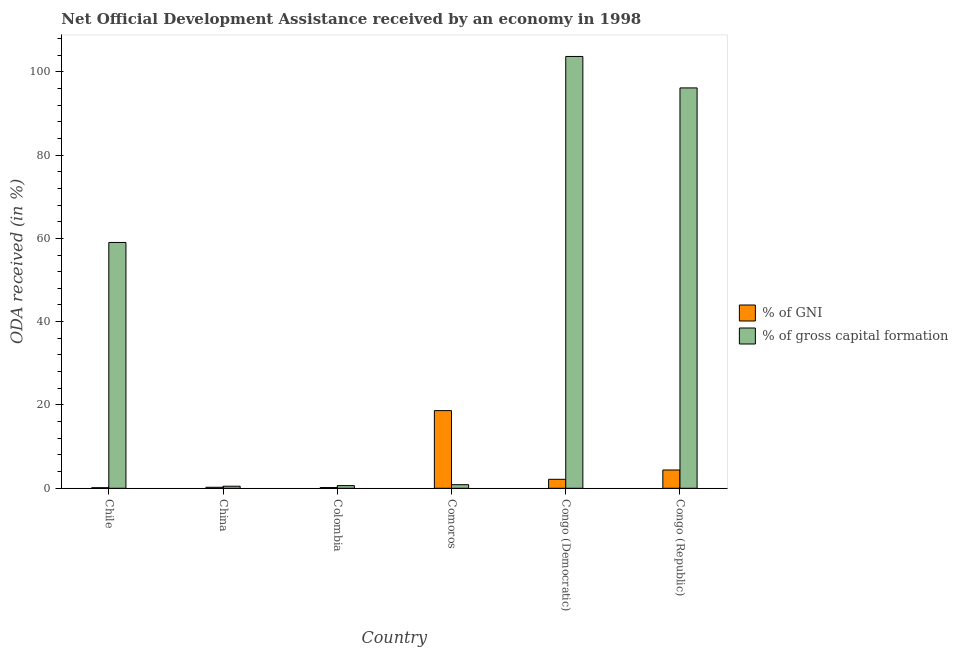How many different coloured bars are there?
Offer a very short reply. 2. Are the number of bars per tick equal to the number of legend labels?
Your response must be concise. Yes. Are the number of bars on each tick of the X-axis equal?
Keep it short and to the point. Yes. How many bars are there on the 2nd tick from the right?
Provide a short and direct response. 2. What is the label of the 6th group of bars from the left?
Give a very brief answer. Congo (Republic). In how many cases, is the number of bars for a given country not equal to the number of legend labels?
Provide a short and direct response. 0. What is the oda received as percentage of gni in Congo (Democratic)?
Provide a short and direct response. 2.15. Across all countries, what is the maximum oda received as percentage of gross capital formation?
Give a very brief answer. 103.67. Across all countries, what is the minimum oda received as percentage of gross capital formation?
Offer a terse response. 0.5. In which country was the oda received as percentage of gross capital formation maximum?
Ensure brevity in your answer.  Congo (Democratic). In which country was the oda received as percentage of gross capital formation minimum?
Make the answer very short. China. What is the total oda received as percentage of gross capital formation in the graph?
Keep it short and to the point. 260.8. What is the difference between the oda received as percentage of gni in Comoros and that in Congo (Republic)?
Give a very brief answer. 14.25. What is the difference between the oda received as percentage of gni in Congo (Republic) and the oda received as percentage of gross capital formation in China?
Ensure brevity in your answer.  3.89. What is the average oda received as percentage of gni per country?
Your answer should be very brief. 4.29. What is the difference between the oda received as percentage of gross capital formation and oda received as percentage of gni in China?
Offer a very short reply. 0.26. In how many countries, is the oda received as percentage of gni greater than 80 %?
Provide a short and direct response. 0. What is the ratio of the oda received as percentage of gross capital formation in Comoros to that in Congo (Republic)?
Your response must be concise. 0.01. Is the oda received as percentage of gross capital formation in China less than that in Comoros?
Provide a short and direct response. Yes. What is the difference between the highest and the second highest oda received as percentage of gross capital formation?
Give a very brief answer. 7.55. What is the difference between the highest and the lowest oda received as percentage of gross capital formation?
Offer a terse response. 103.17. Is the sum of the oda received as percentage of gross capital formation in Chile and Congo (Democratic) greater than the maximum oda received as percentage of gni across all countries?
Offer a very short reply. Yes. What does the 2nd bar from the left in Comoros represents?
Make the answer very short. % of gross capital formation. What does the 1st bar from the right in China represents?
Provide a succinct answer. % of gross capital formation. Are the values on the major ticks of Y-axis written in scientific E-notation?
Ensure brevity in your answer.  No. How are the legend labels stacked?
Keep it short and to the point. Vertical. What is the title of the graph?
Offer a very short reply. Net Official Development Assistance received by an economy in 1998. What is the label or title of the Y-axis?
Your answer should be very brief. ODA received (in %). What is the ODA received (in %) in % of GNI in Chile?
Ensure brevity in your answer.  0.14. What is the ODA received (in %) in % of gross capital formation in Chile?
Provide a succinct answer. 59.01. What is the ODA received (in %) of % of GNI in China?
Make the answer very short. 0.24. What is the ODA received (in %) in % of gross capital formation in China?
Provide a succinct answer. 0.5. What is the ODA received (in %) in % of GNI in Colombia?
Keep it short and to the point. 0.17. What is the ODA received (in %) in % of gross capital formation in Colombia?
Provide a succinct answer. 0.64. What is the ODA received (in %) in % of GNI in Comoros?
Your answer should be compact. 18.64. What is the ODA received (in %) of % of gross capital formation in Comoros?
Ensure brevity in your answer.  0.86. What is the ODA received (in %) in % of GNI in Congo (Democratic)?
Your response must be concise. 2.15. What is the ODA received (in %) in % of gross capital formation in Congo (Democratic)?
Offer a very short reply. 103.67. What is the ODA received (in %) in % of GNI in Congo (Republic)?
Provide a succinct answer. 4.39. What is the ODA received (in %) of % of gross capital formation in Congo (Republic)?
Your answer should be very brief. 96.12. Across all countries, what is the maximum ODA received (in %) of % of GNI?
Give a very brief answer. 18.64. Across all countries, what is the maximum ODA received (in %) in % of gross capital formation?
Give a very brief answer. 103.67. Across all countries, what is the minimum ODA received (in %) of % of GNI?
Make the answer very short. 0.14. Across all countries, what is the minimum ODA received (in %) of % of gross capital formation?
Keep it short and to the point. 0.5. What is the total ODA received (in %) in % of GNI in the graph?
Ensure brevity in your answer.  25.74. What is the total ODA received (in %) of % of gross capital formation in the graph?
Your answer should be very brief. 260.8. What is the difference between the ODA received (in %) in % of GNI in Chile and that in China?
Ensure brevity in your answer.  -0.1. What is the difference between the ODA received (in %) of % of gross capital formation in Chile and that in China?
Your answer should be very brief. 58.52. What is the difference between the ODA received (in %) of % of GNI in Chile and that in Colombia?
Offer a very short reply. -0.04. What is the difference between the ODA received (in %) of % of gross capital formation in Chile and that in Colombia?
Your answer should be compact. 58.37. What is the difference between the ODA received (in %) of % of GNI in Chile and that in Comoros?
Make the answer very short. -18.51. What is the difference between the ODA received (in %) of % of gross capital formation in Chile and that in Comoros?
Your answer should be compact. 58.15. What is the difference between the ODA received (in %) of % of GNI in Chile and that in Congo (Democratic)?
Your answer should be very brief. -2.02. What is the difference between the ODA received (in %) in % of gross capital formation in Chile and that in Congo (Democratic)?
Offer a very short reply. -44.65. What is the difference between the ODA received (in %) in % of GNI in Chile and that in Congo (Republic)?
Your response must be concise. -4.25. What is the difference between the ODA received (in %) in % of gross capital formation in Chile and that in Congo (Republic)?
Your response must be concise. -37.1. What is the difference between the ODA received (in %) of % of GNI in China and that in Colombia?
Give a very brief answer. 0.07. What is the difference between the ODA received (in %) of % of gross capital formation in China and that in Colombia?
Provide a succinct answer. -0.15. What is the difference between the ODA received (in %) in % of GNI in China and that in Comoros?
Make the answer very short. -18.4. What is the difference between the ODA received (in %) of % of gross capital formation in China and that in Comoros?
Offer a terse response. -0.36. What is the difference between the ODA received (in %) in % of GNI in China and that in Congo (Democratic)?
Offer a terse response. -1.91. What is the difference between the ODA received (in %) of % of gross capital formation in China and that in Congo (Democratic)?
Offer a very short reply. -103.17. What is the difference between the ODA received (in %) of % of GNI in China and that in Congo (Republic)?
Give a very brief answer. -4.15. What is the difference between the ODA received (in %) of % of gross capital formation in China and that in Congo (Republic)?
Your response must be concise. -95.62. What is the difference between the ODA received (in %) in % of GNI in Colombia and that in Comoros?
Ensure brevity in your answer.  -18.47. What is the difference between the ODA received (in %) in % of gross capital formation in Colombia and that in Comoros?
Offer a terse response. -0.22. What is the difference between the ODA received (in %) in % of GNI in Colombia and that in Congo (Democratic)?
Your answer should be very brief. -1.98. What is the difference between the ODA received (in %) in % of gross capital formation in Colombia and that in Congo (Democratic)?
Make the answer very short. -103.02. What is the difference between the ODA received (in %) of % of GNI in Colombia and that in Congo (Republic)?
Your answer should be compact. -4.22. What is the difference between the ODA received (in %) of % of gross capital formation in Colombia and that in Congo (Republic)?
Offer a very short reply. -95.47. What is the difference between the ODA received (in %) in % of GNI in Comoros and that in Congo (Democratic)?
Your answer should be very brief. 16.49. What is the difference between the ODA received (in %) in % of gross capital formation in Comoros and that in Congo (Democratic)?
Your response must be concise. -102.81. What is the difference between the ODA received (in %) of % of GNI in Comoros and that in Congo (Republic)?
Your response must be concise. 14.25. What is the difference between the ODA received (in %) of % of gross capital formation in Comoros and that in Congo (Republic)?
Ensure brevity in your answer.  -95.26. What is the difference between the ODA received (in %) of % of GNI in Congo (Democratic) and that in Congo (Republic)?
Provide a short and direct response. -2.24. What is the difference between the ODA received (in %) in % of gross capital formation in Congo (Democratic) and that in Congo (Republic)?
Offer a very short reply. 7.55. What is the difference between the ODA received (in %) in % of GNI in Chile and the ODA received (in %) in % of gross capital formation in China?
Your answer should be compact. -0.36. What is the difference between the ODA received (in %) in % of GNI in Chile and the ODA received (in %) in % of gross capital formation in Colombia?
Make the answer very short. -0.51. What is the difference between the ODA received (in %) of % of GNI in Chile and the ODA received (in %) of % of gross capital formation in Comoros?
Your response must be concise. -0.72. What is the difference between the ODA received (in %) of % of GNI in Chile and the ODA received (in %) of % of gross capital formation in Congo (Democratic)?
Offer a very short reply. -103.53. What is the difference between the ODA received (in %) of % of GNI in Chile and the ODA received (in %) of % of gross capital formation in Congo (Republic)?
Your answer should be very brief. -95.98. What is the difference between the ODA received (in %) of % of GNI in China and the ODA received (in %) of % of gross capital formation in Colombia?
Provide a succinct answer. -0.4. What is the difference between the ODA received (in %) in % of GNI in China and the ODA received (in %) in % of gross capital formation in Comoros?
Your answer should be very brief. -0.62. What is the difference between the ODA received (in %) of % of GNI in China and the ODA received (in %) of % of gross capital formation in Congo (Democratic)?
Ensure brevity in your answer.  -103.42. What is the difference between the ODA received (in %) in % of GNI in China and the ODA received (in %) in % of gross capital formation in Congo (Republic)?
Provide a short and direct response. -95.87. What is the difference between the ODA received (in %) of % of GNI in Colombia and the ODA received (in %) of % of gross capital formation in Comoros?
Make the answer very short. -0.69. What is the difference between the ODA received (in %) in % of GNI in Colombia and the ODA received (in %) in % of gross capital formation in Congo (Democratic)?
Provide a succinct answer. -103.49. What is the difference between the ODA received (in %) in % of GNI in Colombia and the ODA received (in %) in % of gross capital formation in Congo (Republic)?
Offer a terse response. -95.94. What is the difference between the ODA received (in %) in % of GNI in Comoros and the ODA received (in %) in % of gross capital formation in Congo (Democratic)?
Make the answer very short. -85.02. What is the difference between the ODA received (in %) of % of GNI in Comoros and the ODA received (in %) of % of gross capital formation in Congo (Republic)?
Your answer should be compact. -77.47. What is the difference between the ODA received (in %) of % of GNI in Congo (Democratic) and the ODA received (in %) of % of gross capital formation in Congo (Republic)?
Your response must be concise. -93.96. What is the average ODA received (in %) in % of GNI per country?
Give a very brief answer. 4.29. What is the average ODA received (in %) in % of gross capital formation per country?
Provide a short and direct response. 43.47. What is the difference between the ODA received (in %) in % of GNI and ODA received (in %) in % of gross capital formation in Chile?
Make the answer very short. -58.88. What is the difference between the ODA received (in %) in % of GNI and ODA received (in %) in % of gross capital formation in China?
Make the answer very short. -0.26. What is the difference between the ODA received (in %) of % of GNI and ODA received (in %) of % of gross capital formation in Colombia?
Ensure brevity in your answer.  -0.47. What is the difference between the ODA received (in %) in % of GNI and ODA received (in %) in % of gross capital formation in Comoros?
Make the answer very short. 17.78. What is the difference between the ODA received (in %) in % of GNI and ODA received (in %) in % of gross capital formation in Congo (Democratic)?
Make the answer very short. -101.51. What is the difference between the ODA received (in %) of % of GNI and ODA received (in %) of % of gross capital formation in Congo (Republic)?
Your response must be concise. -91.73. What is the ratio of the ODA received (in %) in % of GNI in Chile to that in China?
Give a very brief answer. 0.57. What is the ratio of the ODA received (in %) of % of gross capital formation in Chile to that in China?
Provide a short and direct response. 118.5. What is the ratio of the ODA received (in %) of % of GNI in Chile to that in Colombia?
Your response must be concise. 0.79. What is the ratio of the ODA received (in %) of % of gross capital formation in Chile to that in Colombia?
Offer a very short reply. 91.53. What is the ratio of the ODA received (in %) of % of GNI in Chile to that in Comoros?
Offer a very short reply. 0.01. What is the ratio of the ODA received (in %) in % of gross capital formation in Chile to that in Comoros?
Your response must be concise. 68.6. What is the ratio of the ODA received (in %) in % of GNI in Chile to that in Congo (Democratic)?
Ensure brevity in your answer.  0.06. What is the ratio of the ODA received (in %) of % of gross capital formation in Chile to that in Congo (Democratic)?
Your answer should be compact. 0.57. What is the ratio of the ODA received (in %) in % of GNI in Chile to that in Congo (Republic)?
Your response must be concise. 0.03. What is the ratio of the ODA received (in %) of % of gross capital formation in Chile to that in Congo (Republic)?
Offer a very short reply. 0.61. What is the ratio of the ODA received (in %) of % of GNI in China to that in Colombia?
Your answer should be compact. 1.4. What is the ratio of the ODA received (in %) of % of gross capital formation in China to that in Colombia?
Your answer should be very brief. 0.77. What is the ratio of the ODA received (in %) of % of GNI in China to that in Comoros?
Give a very brief answer. 0.01. What is the ratio of the ODA received (in %) of % of gross capital formation in China to that in Comoros?
Provide a short and direct response. 0.58. What is the ratio of the ODA received (in %) of % of GNI in China to that in Congo (Democratic)?
Ensure brevity in your answer.  0.11. What is the ratio of the ODA received (in %) of % of gross capital formation in China to that in Congo (Democratic)?
Give a very brief answer. 0. What is the ratio of the ODA received (in %) of % of GNI in China to that in Congo (Republic)?
Ensure brevity in your answer.  0.06. What is the ratio of the ODA received (in %) of % of gross capital formation in China to that in Congo (Republic)?
Make the answer very short. 0.01. What is the ratio of the ODA received (in %) of % of GNI in Colombia to that in Comoros?
Keep it short and to the point. 0.01. What is the ratio of the ODA received (in %) of % of gross capital formation in Colombia to that in Comoros?
Your answer should be compact. 0.75. What is the ratio of the ODA received (in %) in % of GNI in Colombia to that in Congo (Democratic)?
Your answer should be compact. 0.08. What is the ratio of the ODA received (in %) in % of gross capital formation in Colombia to that in Congo (Democratic)?
Give a very brief answer. 0.01. What is the ratio of the ODA received (in %) of % of GNI in Colombia to that in Congo (Republic)?
Provide a short and direct response. 0.04. What is the ratio of the ODA received (in %) in % of gross capital formation in Colombia to that in Congo (Republic)?
Your response must be concise. 0.01. What is the ratio of the ODA received (in %) of % of GNI in Comoros to that in Congo (Democratic)?
Provide a short and direct response. 8.66. What is the ratio of the ODA received (in %) in % of gross capital formation in Comoros to that in Congo (Democratic)?
Ensure brevity in your answer.  0.01. What is the ratio of the ODA received (in %) in % of GNI in Comoros to that in Congo (Republic)?
Give a very brief answer. 4.25. What is the ratio of the ODA received (in %) in % of gross capital formation in Comoros to that in Congo (Republic)?
Offer a terse response. 0.01. What is the ratio of the ODA received (in %) in % of GNI in Congo (Democratic) to that in Congo (Republic)?
Provide a short and direct response. 0.49. What is the ratio of the ODA received (in %) in % of gross capital formation in Congo (Democratic) to that in Congo (Republic)?
Your answer should be very brief. 1.08. What is the difference between the highest and the second highest ODA received (in %) of % of GNI?
Make the answer very short. 14.25. What is the difference between the highest and the second highest ODA received (in %) in % of gross capital formation?
Offer a very short reply. 7.55. What is the difference between the highest and the lowest ODA received (in %) in % of GNI?
Ensure brevity in your answer.  18.51. What is the difference between the highest and the lowest ODA received (in %) of % of gross capital formation?
Keep it short and to the point. 103.17. 